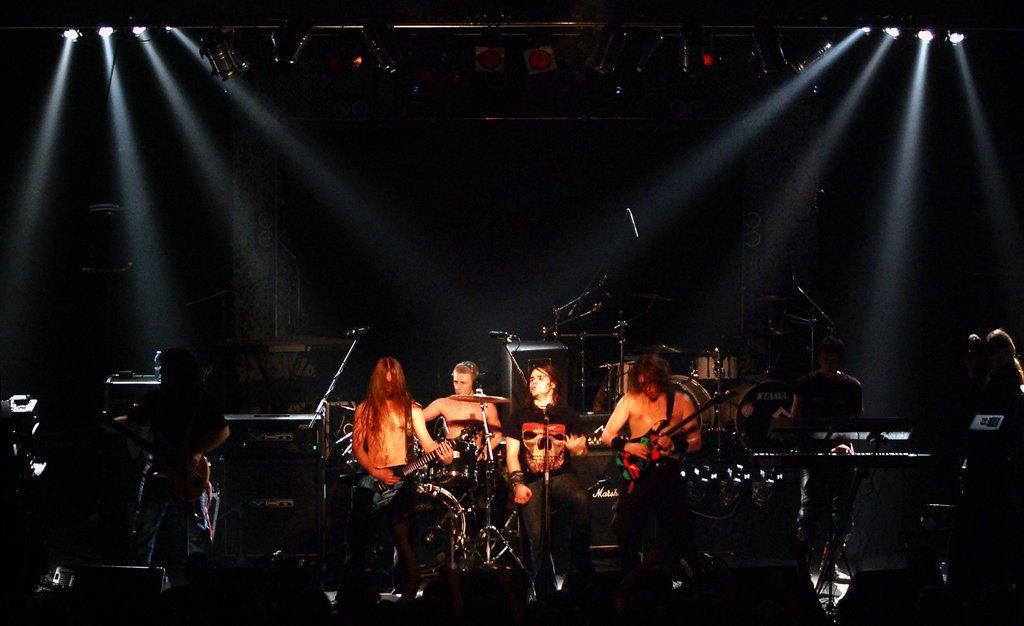Describe this image in one or two sentences. There are four persons standing. On the right end a person is holding guitar and playing. In the middle there is a mic stand. He is singing. And in the back there is a person playing drums. And in the left corner a person is playing guitar. And there are lights in the ceiling. 